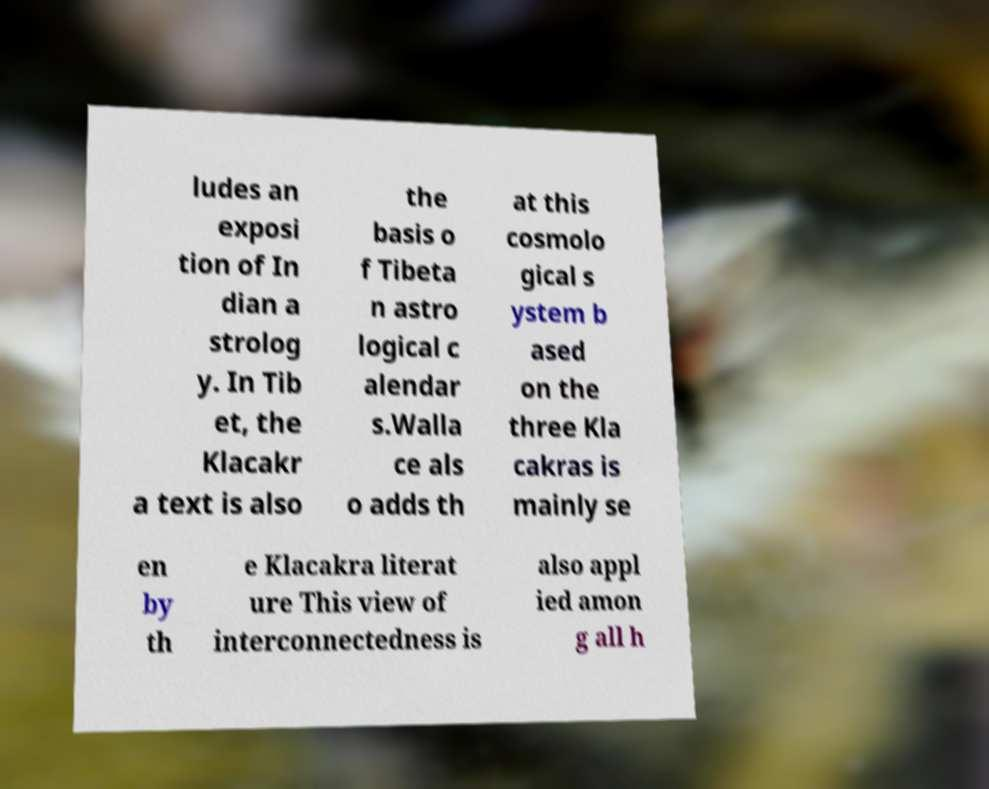There's text embedded in this image that I need extracted. Can you transcribe it verbatim? ludes an exposi tion of In dian a strolog y. In Tib et, the Klacakr a text is also the basis o f Tibeta n astro logical c alendar s.Walla ce als o adds th at this cosmolo gical s ystem b ased on the three Kla cakras is mainly se en by th e Klacakra literat ure This view of interconnectedness is also appl ied amon g all h 